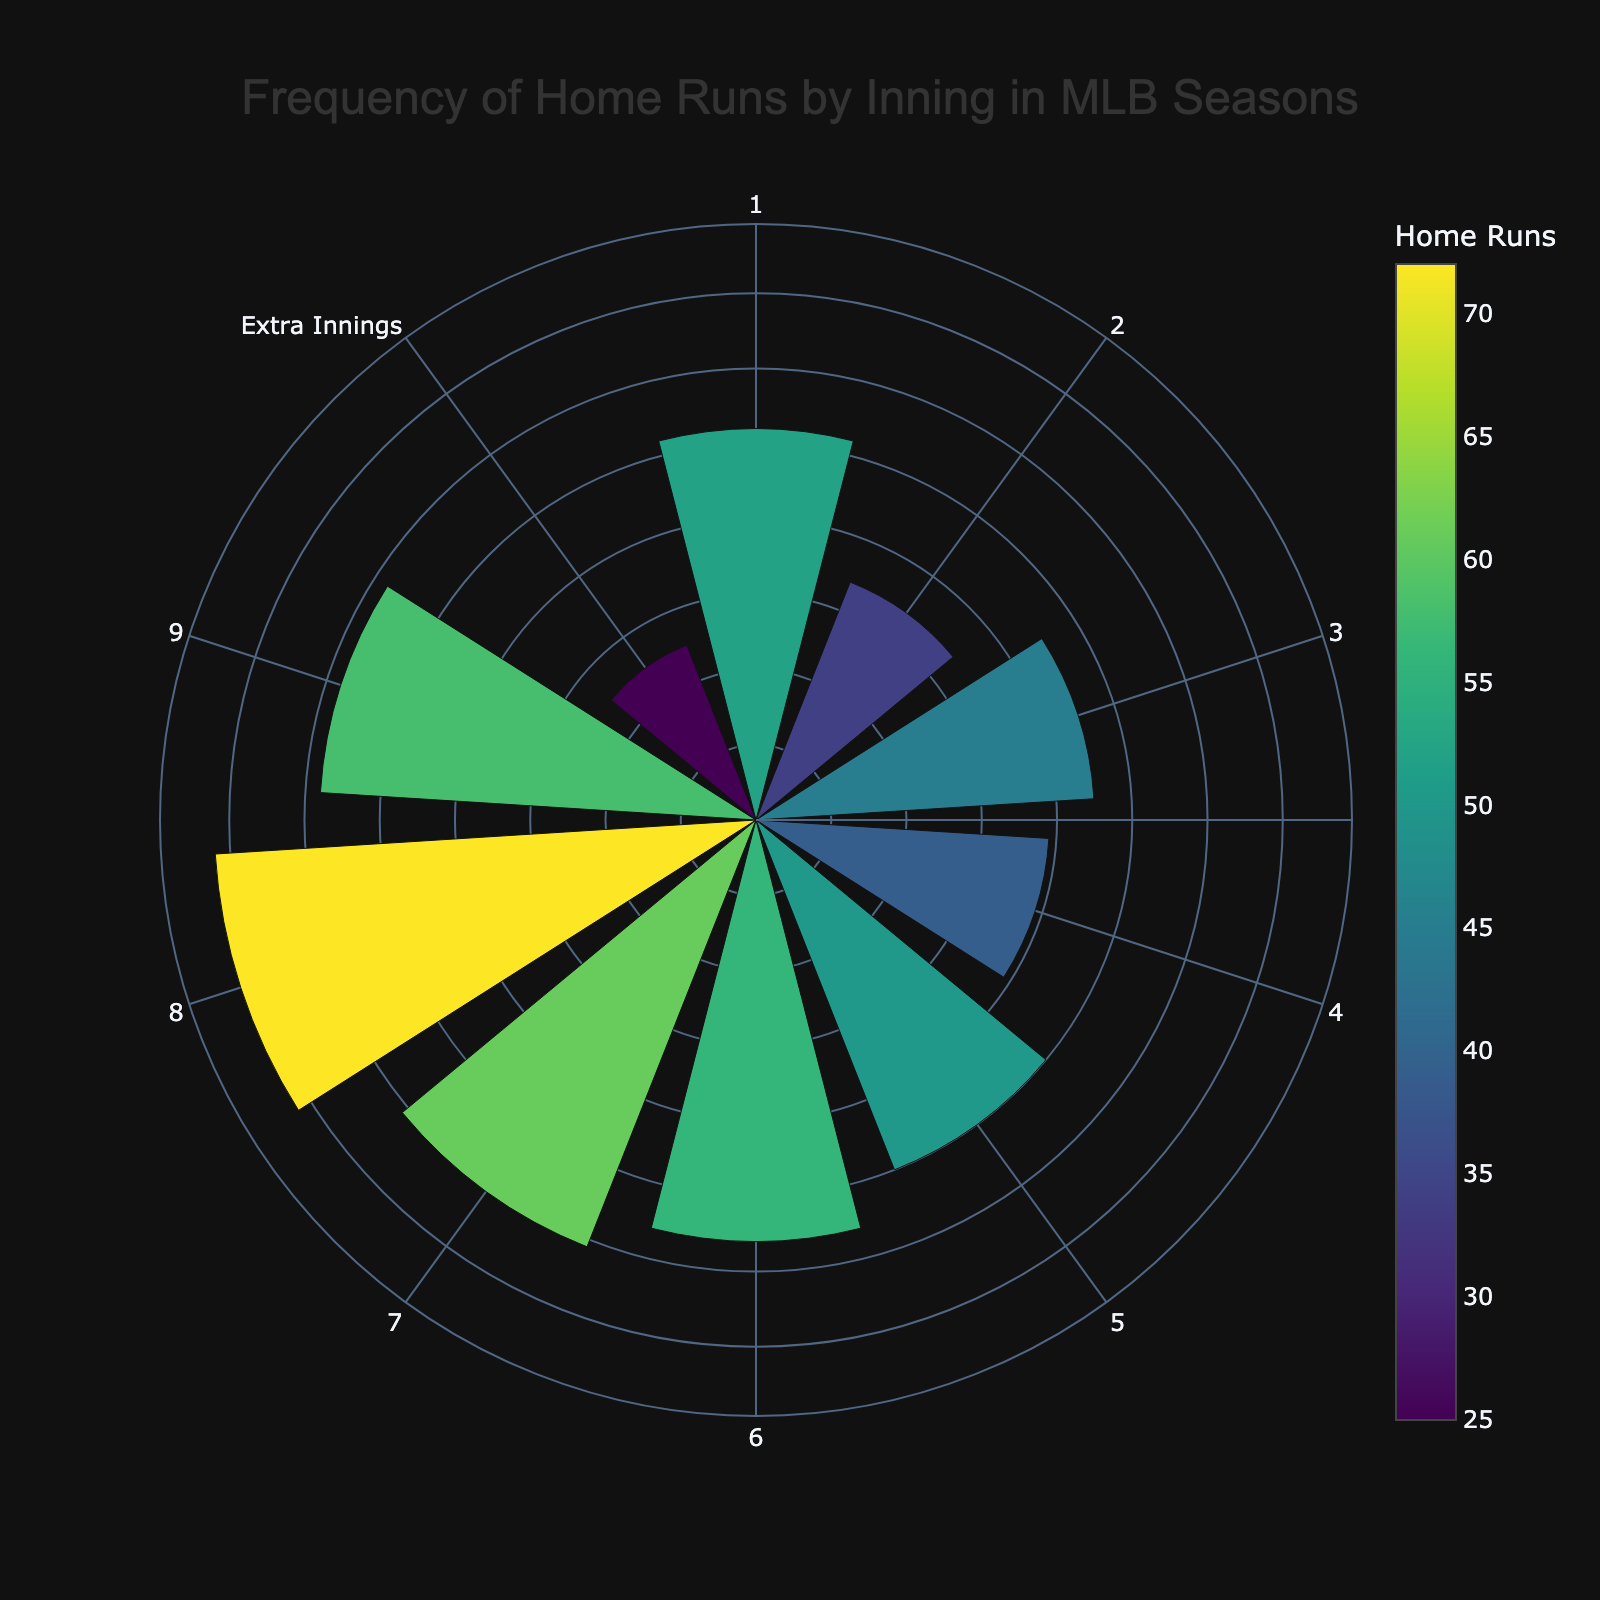what's the title of the figure? The title of the figure is usually placed at the top of the plot and here it reads "Frequency of Home Runs by Inning in MLB Seasons".
Answer: Frequency of Home Runs by Inning in MLB Seasons how many home runs were hit in the 7th inning? The figure provides a visual representation of home runs by inning. By looking at the segment corresponding to the 7th inning, you can see that 61 home runs were hit.
Answer: 61 which inning had the highest frequency of home runs? To find the inning with the highest frequency, we observe the length of the bars in the rose chart. The 8th inning segment is the longest, indicating it had the highest frequency of home runs.
Answer: 8th inning compare the frequency of home runs in the 3rd and 5th innings. Which is greater? By visual comparison of the bars for the 3rd and 5th innings, it is clear that the 5th inning bar is longer than the 3rd inning bar, indicating more home runs were hit in the 5th inning.
Answer: 5th inning how many more home runs were hit in the 9th inning compared to extra innings? Check the lengths of the segments for the 9th inning and extra innings. The 9th inning had 58 home runs, while extra innings had 25. Subtract 25 from 58 to find the difference.
Answer: 33 which inning had the least number of home runs and how many was it? Look for the shortest segment in the rose chart. The extra innings segment is the shortest, indicating it had the least number of home runs, which is 25.
Answer: Extra innings, 25 what's the total number of home runs hit from inning 6 through 8? To find the total, sum the values of home runs for the 6th, 7th, and 8th innings: 56 + 61 + 72.
Answer: 189 on average, how many home runs were hit per inning from the 1st to the 9th inning? First, sum the home runs from the 1st to the 9th inning: 52 + 34 + 45 + 39 + 50 + 56 + 61 + 72 + 58. Then divide this total by the number of innings, which is 9.
Answer: 51.9 what's the difference in home runs between the inning with the most home runs and the inning with the least home runs? The inning with the most home runs is the 8th (72 home runs) and the inning with the least is extra innings (25 home runs). Subtract 25 from 72 for the difference.
Answer: 47 which three innings have the highest frequency of home runs? Observe the three longest segments in the rose chart. They correspond to the 8th, 9th, and 7th innings, which are the top three in terms of frequency of home runs.
Answer: 8th, 9th, 7th 